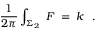Convert formula to latex. <formula><loc_0><loc_0><loc_500><loc_500>{ \frac { 1 } { 2 \pi } } \int _ { \Sigma _ { 2 } } \, F \, = \, k \ \ .</formula> 